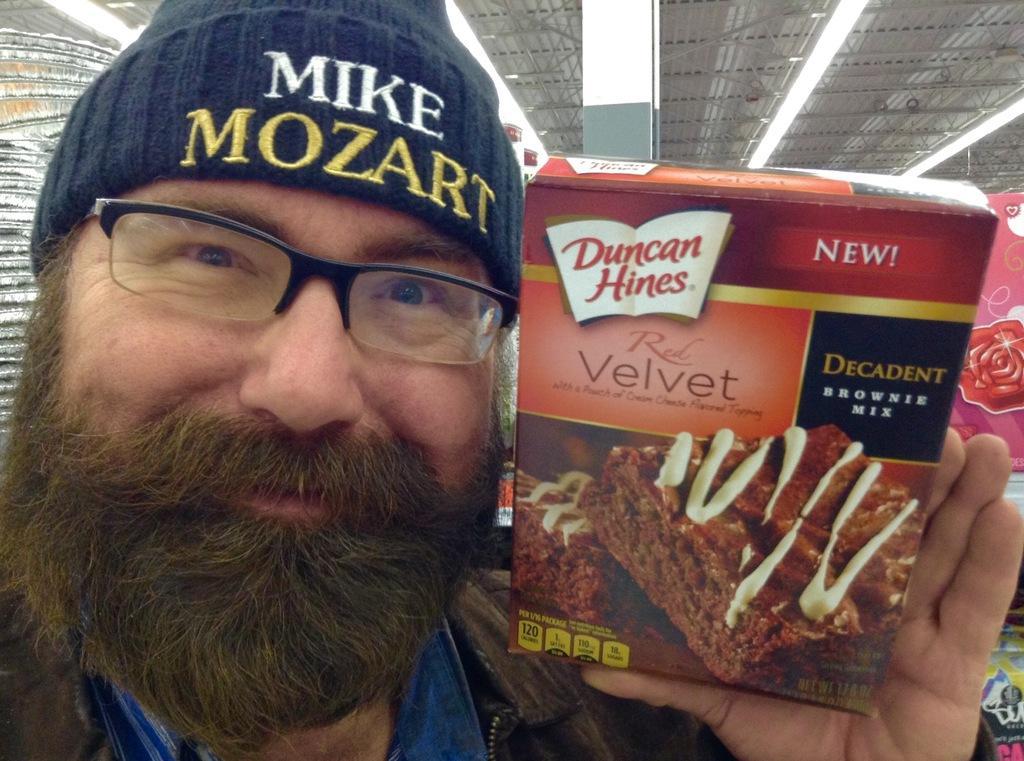Could you give a brief overview of what you see in this image? In this picture there is a man with beard on the face standing in the front, smiling and holding the cake box in the hand. Above there is a iron shed and lights. 